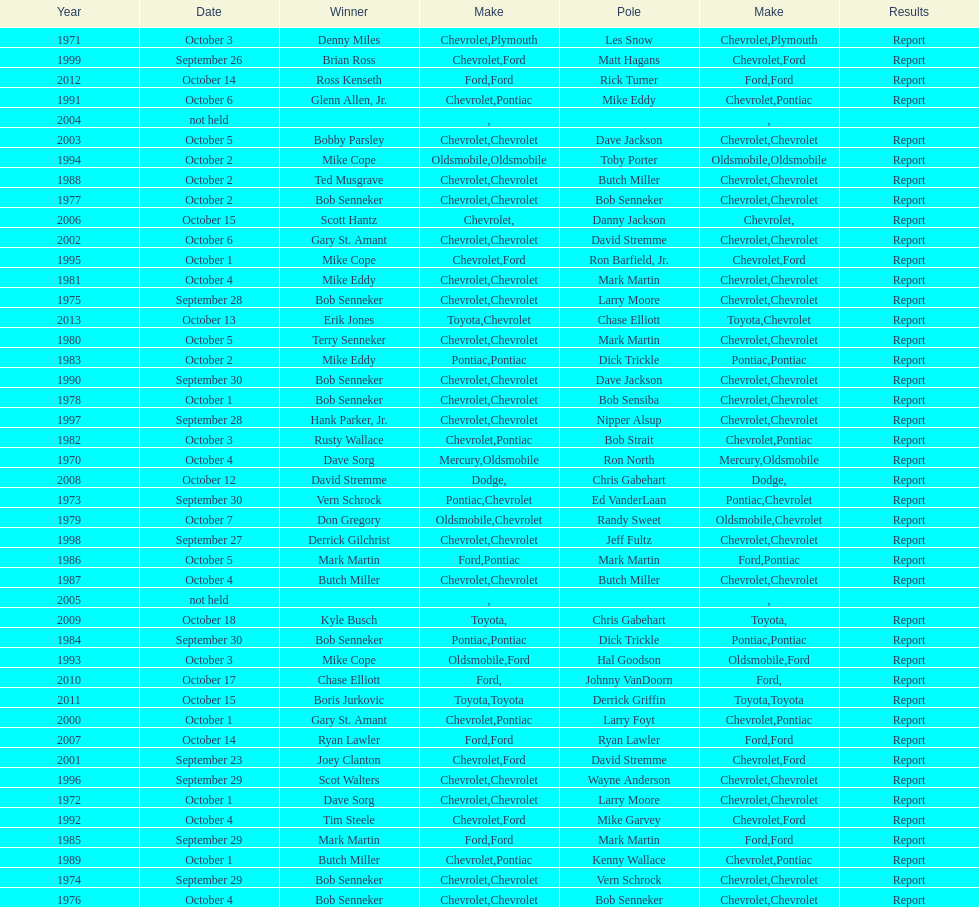Which make of car was used the least by those that won races? Toyota. 